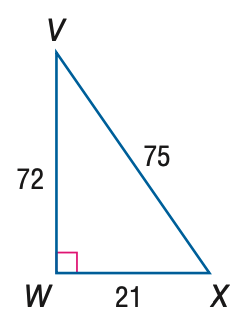Answer the mathemtical geometry problem and directly provide the correct option letter.
Question: Express the ratio of \tan V as a decimal to the nearest hundredth.
Choices: A: 0.28 B: 0.29 C: 0.96 D: 3.43 B 